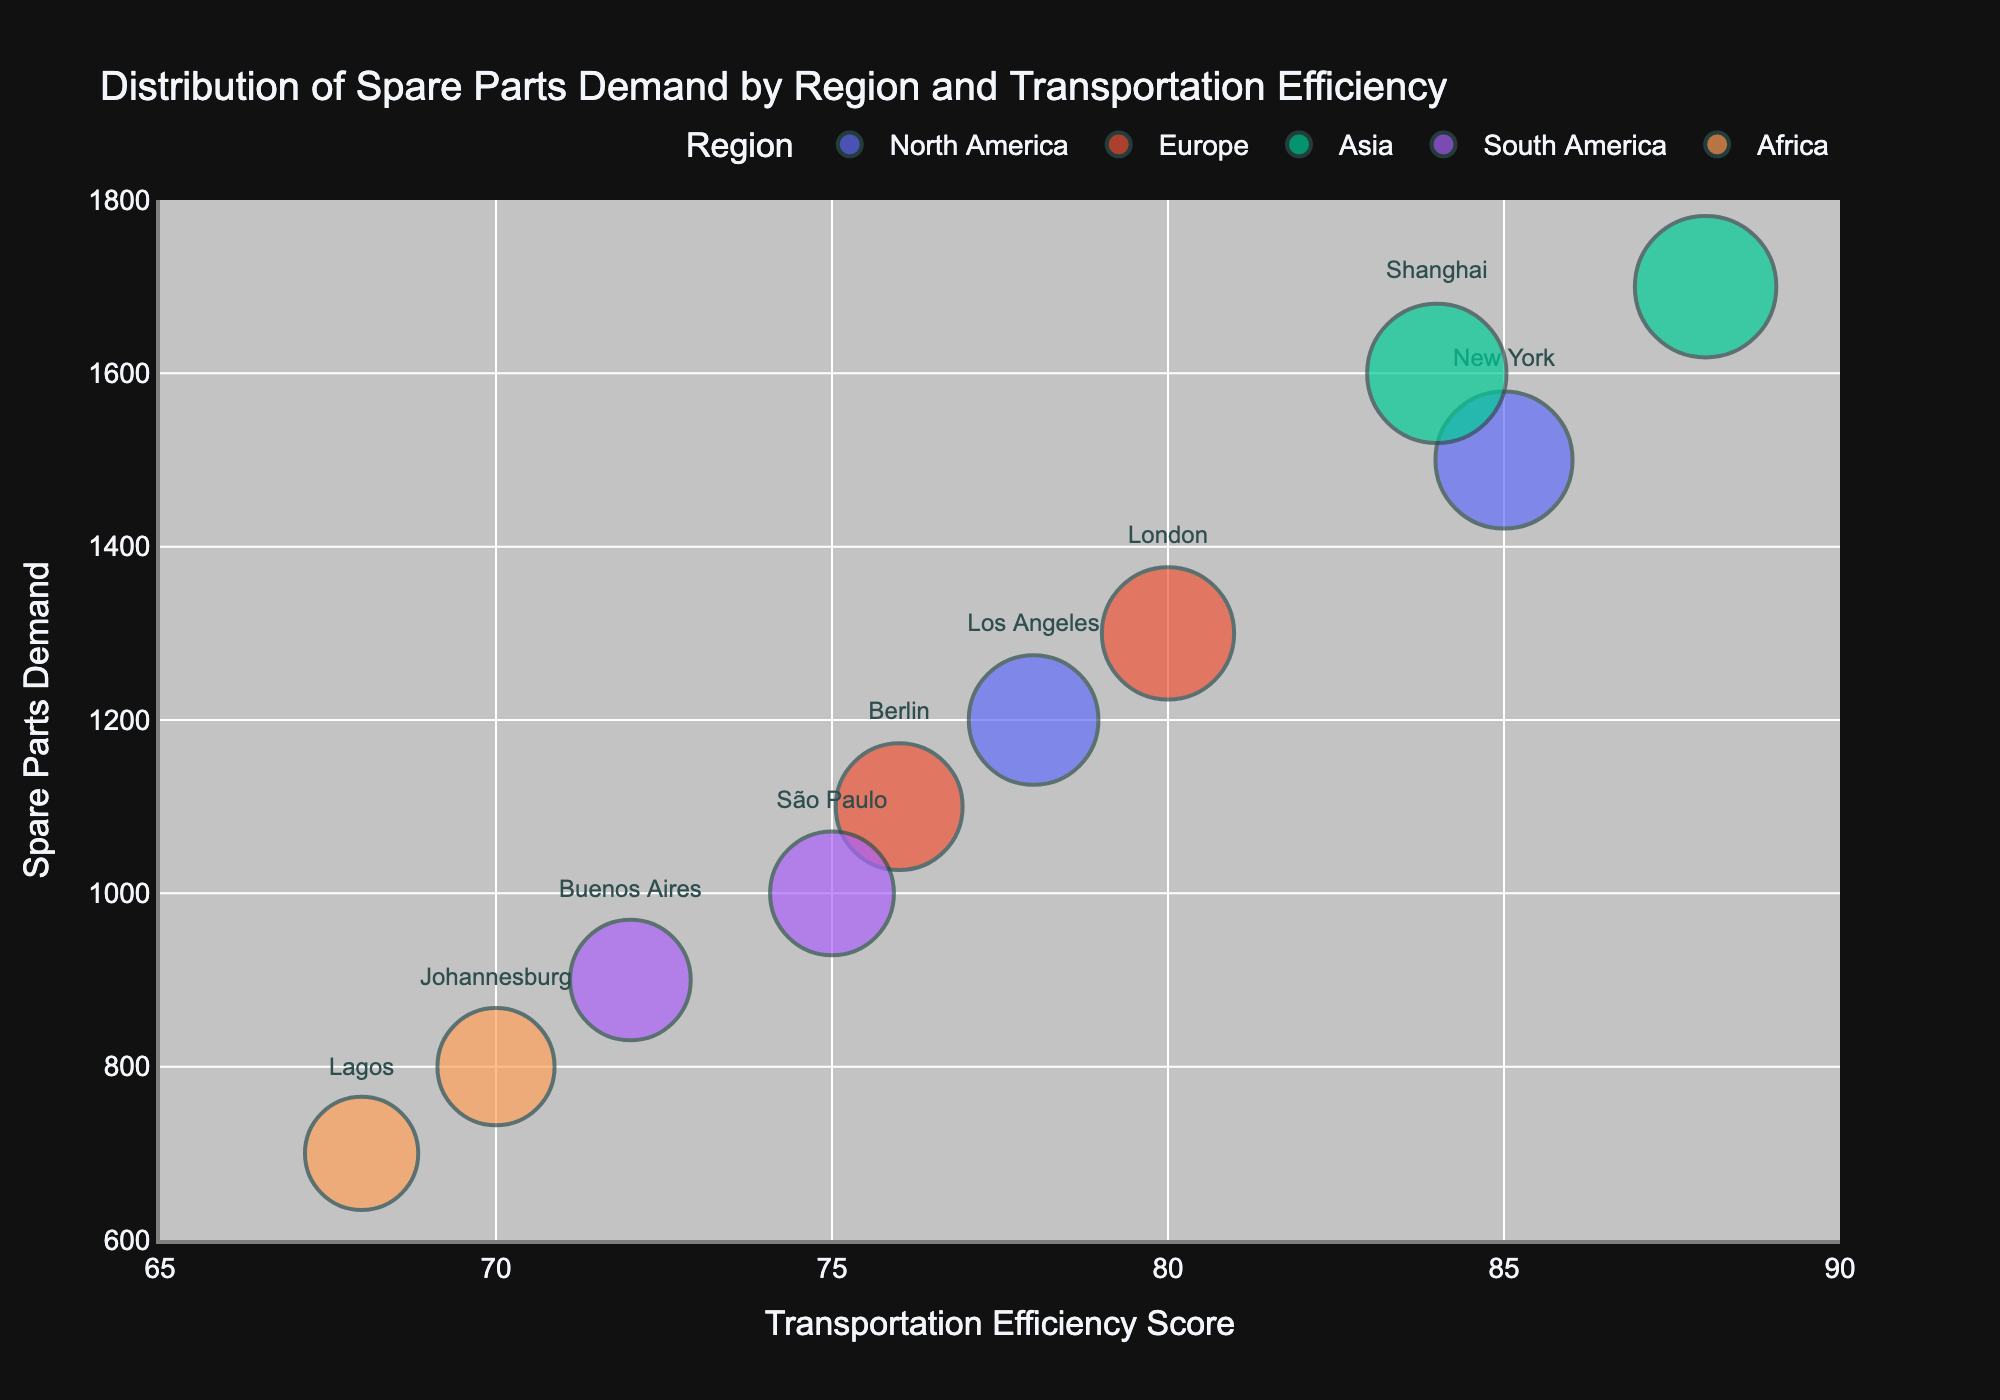What is the title of the chart? The title of the chart is displayed at the top and reads 'Distribution of Spare Parts Demand by Region and Transportation Efficiency'.
Answer: Distribution of Spare Parts Demand by Region and Transportation Efficiency Which region has the highest transportation efficiency score? By examining the x-axis, Asia has the city Tokyo with the highest transportation efficiency score of 88.
Answer: Asia What is the spare parts demand for New York? Finding the bubble labeled 'New York', it is positioned at a demand of 1500 on the y-axis.
Answer: 1500 Which city has the smallest bubble size and what is its demand? The smallest bubble indicates the smallest spare parts demand. Lagos is the city with the smallest bubble, positioned at 700 on the y-axis.
Answer: Lagos, 700 How does the transportation efficiency score of Los Angeles compare to São Paulo? Los Angeles has a transportation efficiency score of 78, while São Paulo's score is 75. This means Los Angeles has a higher score by 3 points.
Answer: Los Angeles is higher by 3 points Which city in Europe has the higher spare parts demand? Comparing London's and Berlin's positions on the y-axis, London has a spare parts demand of 1300, while Berlin has 1100. Therefore, London has the higher demand.
Answer: London What is the average transportation efficiency score of cities in Africa? The transportation efficiency scores for Johannesburg and Lagos are 70 and 68, respectively. The average is (70 + 68) / 2 = 69.
Answer: 69 Which region appears to be the most efficient in terms of transportation efficiency? By observing which region's cities have the highest scores on the x-axis, Asia's cities (Tokyo at 88 and Shanghai at 84) have the highest scores.
Answer: Asia How many regions are represented in the bubble chart? Counting the distinct regions indicated by different colors in the legend, there are five regions.
Answer: 5 What is the difference in spare parts demand between São Paulo and Buenos Aires? São Paulo's demand is 1000, and Buenos Aires's demand is 900. The difference is 1000 - 900 = 100.
Answer: 100 